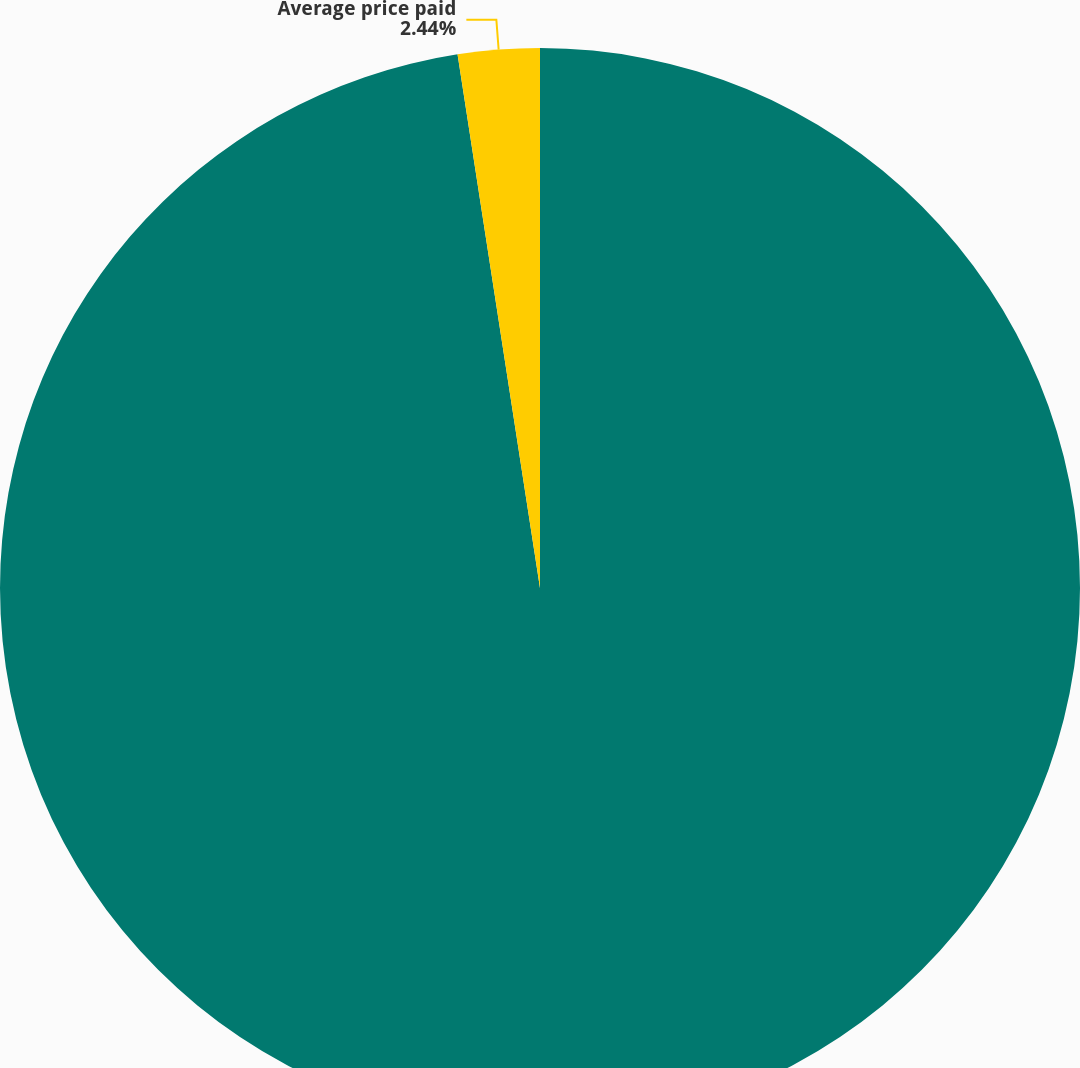Convert chart. <chart><loc_0><loc_0><loc_500><loc_500><pie_chart><fcel>Number of shares<fcel>Average price paid<nl><fcel>97.56%<fcel>2.44%<nl></chart> 